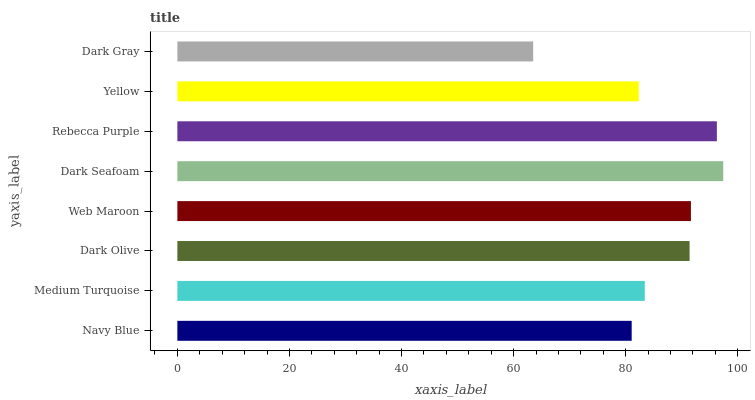Is Dark Gray the minimum?
Answer yes or no. Yes. Is Dark Seafoam the maximum?
Answer yes or no. Yes. Is Medium Turquoise the minimum?
Answer yes or no. No. Is Medium Turquoise the maximum?
Answer yes or no. No. Is Medium Turquoise greater than Navy Blue?
Answer yes or no. Yes. Is Navy Blue less than Medium Turquoise?
Answer yes or no. Yes. Is Navy Blue greater than Medium Turquoise?
Answer yes or no. No. Is Medium Turquoise less than Navy Blue?
Answer yes or no. No. Is Dark Olive the high median?
Answer yes or no. Yes. Is Medium Turquoise the low median?
Answer yes or no. Yes. Is Web Maroon the high median?
Answer yes or no. No. Is Web Maroon the low median?
Answer yes or no. No. 